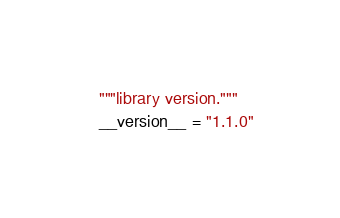<code> <loc_0><loc_0><loc_500><loc_500><_Python_>"""library version."""
__version__ = "1.1.0"
</code> 